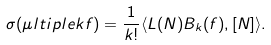Convert formula to latex. <formula><loc_0><loc_0><loc_500><loc_500>\sigma ( \mu l t i p l e { k } { f } ) = \frac { 1 } { k ! } \langle L ( N ) B _ { k } ( f ) , [ N ] \rangle .</formula> 